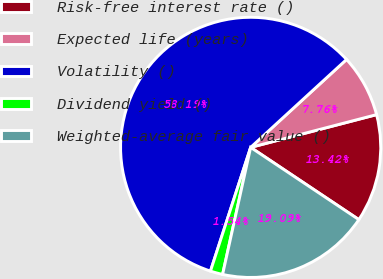Convert chart. <chart><loc_0><loc_0><loc_500><loc_500><pie_chart><fcel>Risk-free interest rate ()<fcel>Expected life (years)<fcel>Volatility ()<fcel>Dividend yield ()<fcel>Weighted-average fair value ()<nl><fcel>13.42%<fcel>7.76%<fcel>58.19%<fcel>1.54%<fcel>19.09%<nl></chart> 